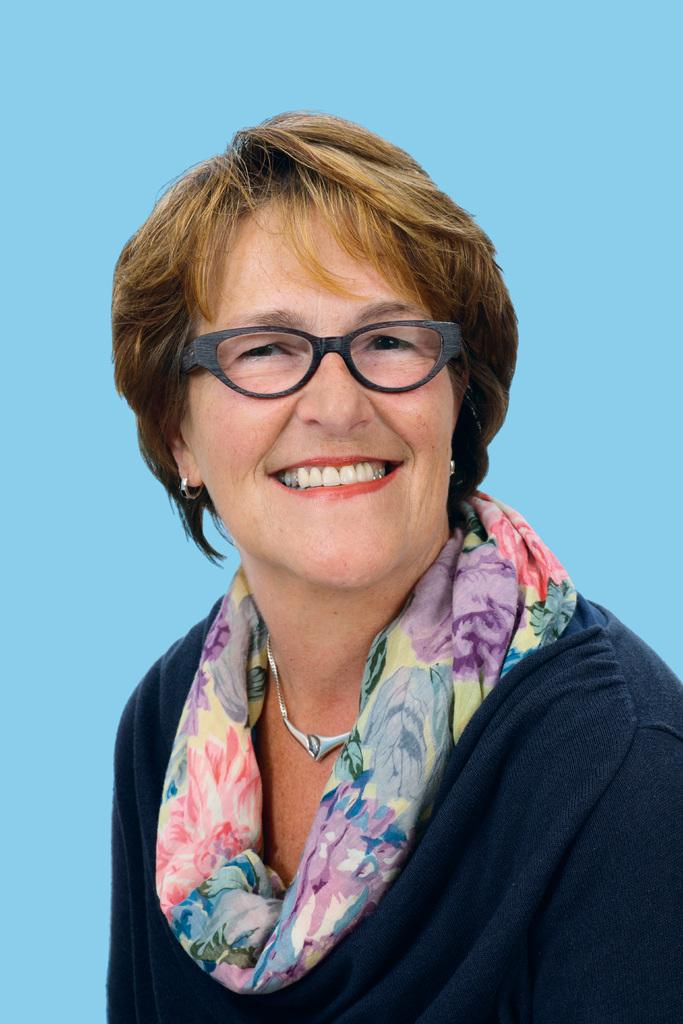Who is present in the image? There is a woman in the image. What is the woman's facial expression? The woman is smiling. What accessories is the woman wearing? The woman is wearing glasses and a scarf. What color is the background of the image? The background of the image is blue. How many pizzas are visible in the image? There are no pizzas present in the image. Is the woman wearing a veil in the image? No, the woman is wearing a scarf, not a veil, in the image. 